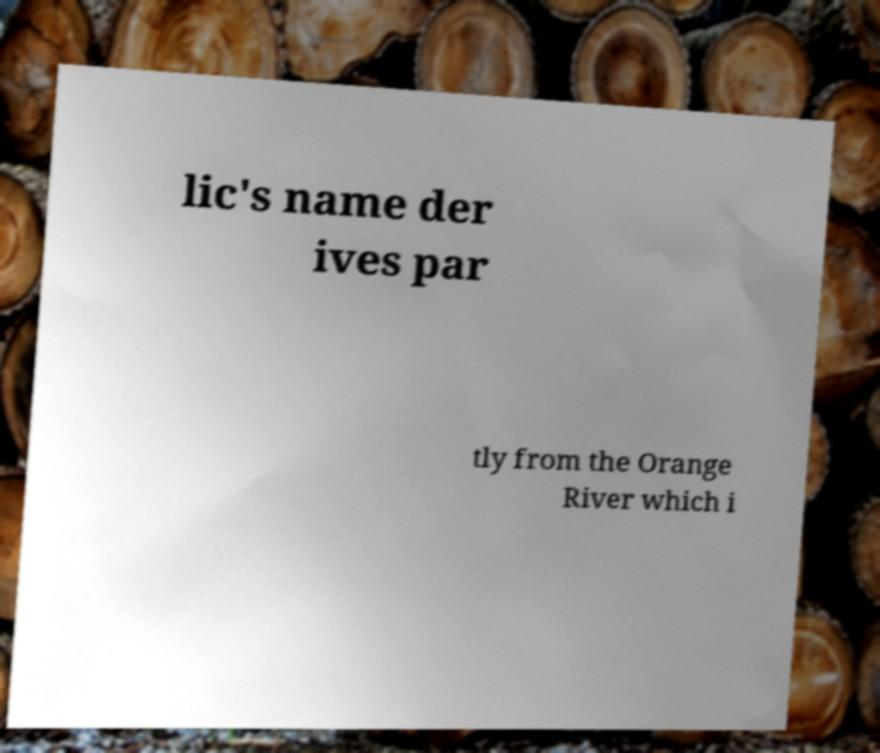For documentation purposes, I need the text within this image transcribed. Could you provide that? lic's name der ives par tly from the Orange River which i 